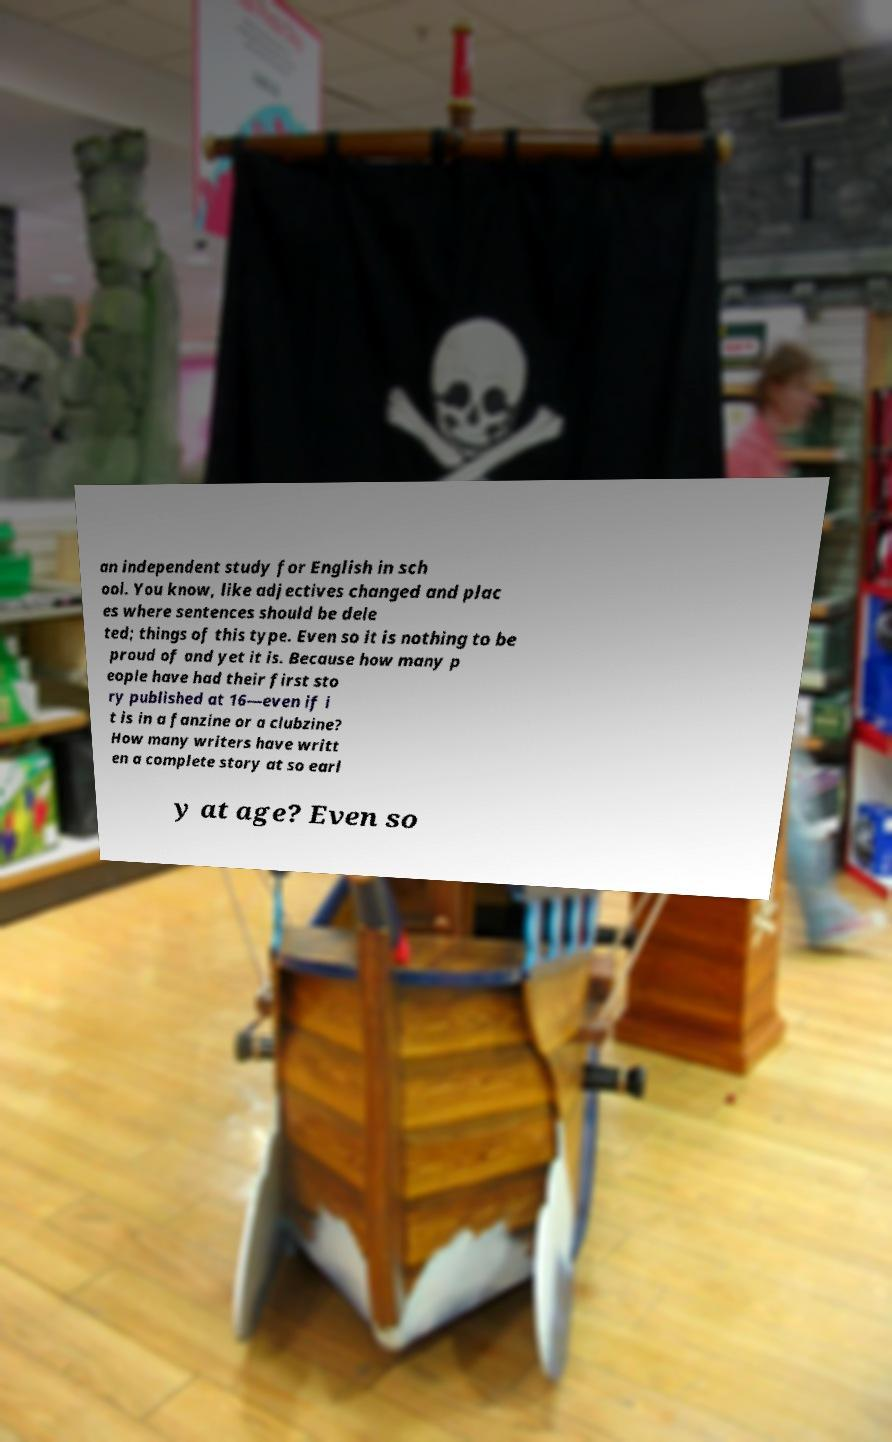Could you extract and type out the text from this image? an independent study for English in sch ool. You know, like adjectives changed and plac es where sentences should be dele ted; things of this type. Even so it is nothing to be proud of and yet it is. Because how many p eople have had their first sto ry published at 16—even if i t is in a fanzine or a clubzine? How many writers have writt en a complete story at so earl y at age? Even so 